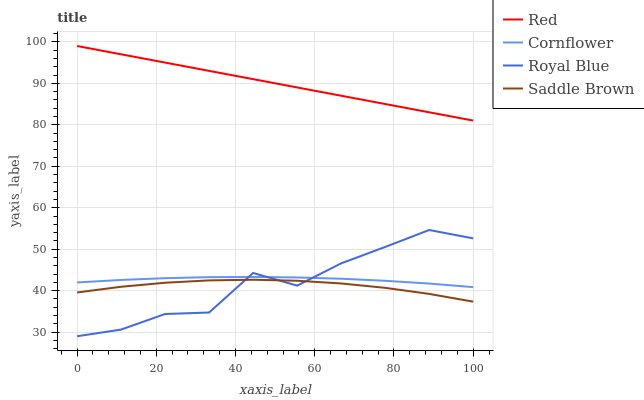Does Saddle Brown have the minimum area under the curve?
Answer yes or no. Yes. Does Red have the maximum area under the curve?
Answer yes or no. Yes. Does Red have the minimum area under the curve?
Answer yes or no. No. Does Saddle Brown have the maximum area under the curve?
Answer yes or no. No. Is Red the smoothest?
Answer yes or no. Yes. Is Royal Blue the roughest?
Answer yes or no. Yes. Is Saddle Brown the smoothest?
Answer yes or no. No. Is Saddle Brown the roughest?
Answer yes or no. No. Does Royal Blue have the lowest value?
Answer yes or no. Yes. Does Saddle Brown have the lowest value?
Answer yes or no. No. Does Red have the highest value?
Answer yes or no. Yes. Does Saddle Brown have the highest value?
Answer yes or no. No. Is Royal Blue less than Red?
Answer yes or no. Yes. Is Red greater than Saddle Brown?
Answer yes or no. Yes. Does Royal Blue intersect Saddle Brown?
Answer yes or no. Yes. Is Royal Blue less than Saddle Brown?
Answer yes or no. No. Is Royal Blue greater than Saddle Brown?
Answer yes or no. No. Does Royal Blue intersect Red?
Answer yes or no. No. 